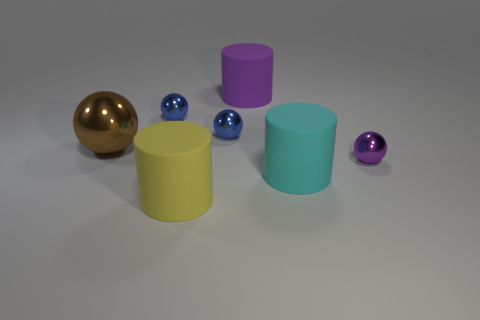Can you describe the arrangement of objects in this image? Certainly. The image contains five objects arranged on a surface: two cylinders and three spheres. On the left, there is a large gold sphere, and next to it, two cylinders, one cyan and one yellow, are positioned side by side. Near the center, a smaller blue sphere rests in front of the cyan cylinder, and finally, a small purple sphere is in front of the yellow cylinder. 